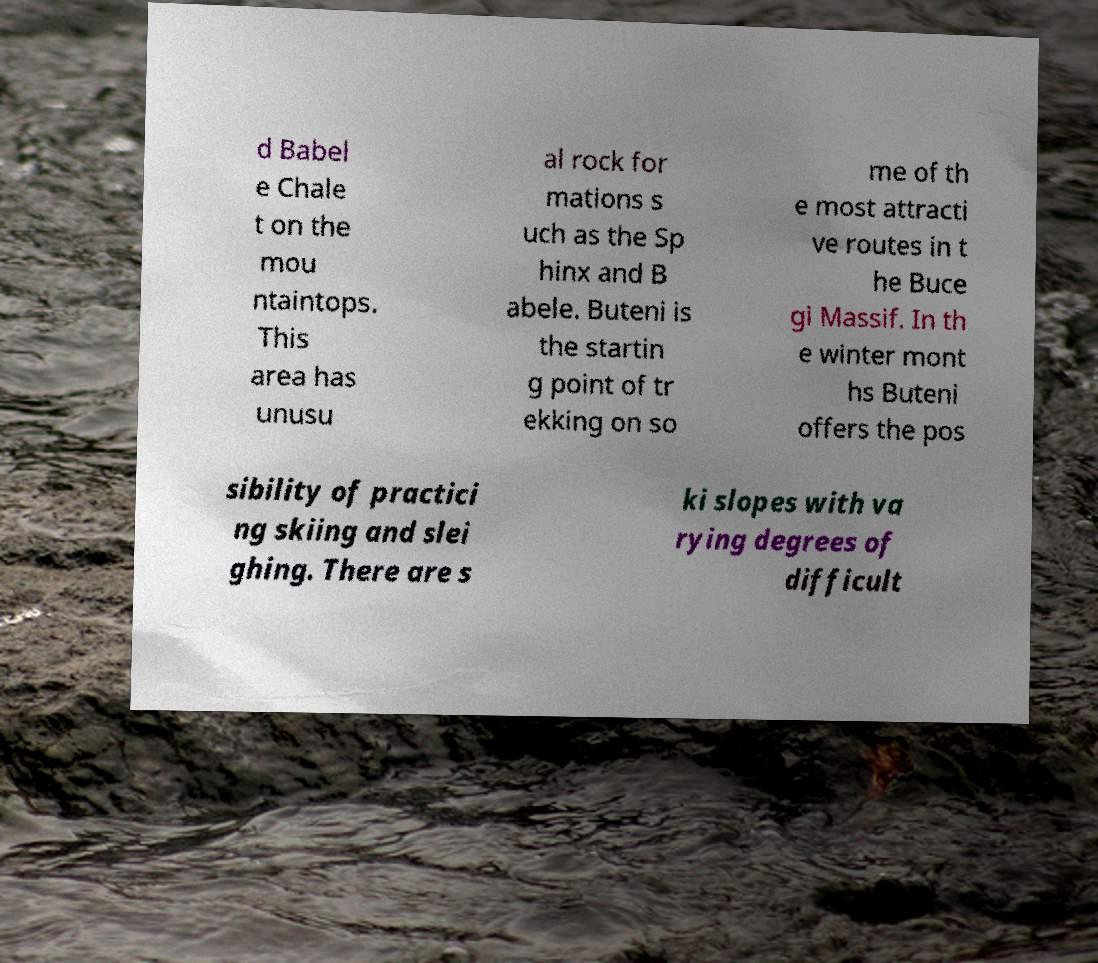Could you assist in decoding the text presented in this image and type it out clearly? d Babel e Chale t on the mou ntaintops. This area has unusu al rock for mations s uch as the Sp hinx and B abele. Buteni is the startin g point of tr ekking on so me of th e most attracti ve routes in t he Buce gi Massif. In th e winter mont hs Buteni offers the pos sibility of practici ng skiing and slei ghing. There are s ki slopes with va rying degrees of difficult 